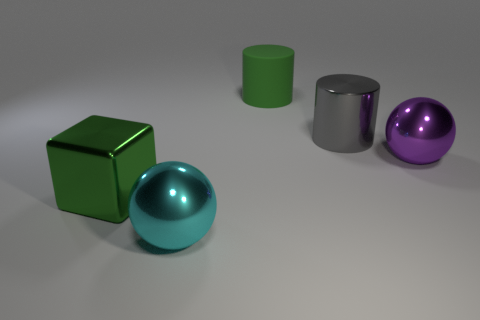Is there any other thing that is the same material as the big green cylinder?
Give a very brief answer. No. There is a ball that is to the left of the large gray cylinder; what is its size?
Provide a succinct answer. Large. What size is the green cube that is the same material as the purple object?
Ensure brevity in your answer.  Large. Are there more large shiny blocks than brown metal spheres?
Your answer should be very brief. Yes. What number of other things are the same color as the big block?
Your answer should be very brief. 1. What number of objects are both in front of the matte cylinder and behind the large shiny block?
Your response must be concise. 2. Is there anything else that is the same size as the cyan metal ball?
Keep it short and to the point. Yes. Are there more cyan objects that are in front of the large gray cylinder than spheres that are in front of the cyan metallic thing?
Your answer should be compact. Yes. There is a cylinder in front of the big matte object; what material is it?
Provide a short and direct response. Metal. Do the large gray object and the green object on the left side of the big matte thing have the same shape?
Ensure brevity in your answer.  No. 